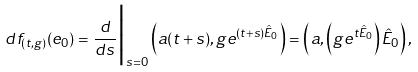Convert formula to latex. <formula><loc_0><loc_0><loc_500><loc_500>d f _ { ( t , g ) } ( e _ { 0 } ) = \frac { d } { d s } \Big | _ { s = 0 } \left ( a ( t + s ) , g e ^ { ( t + s ) \hat { E } _ { 0 } } \right ) = \left ( a , \left ( g e ^ { t \hat { E } _ { 0 } } \right ) \hat { E } _ { 0 } \right ) ,</formula> 